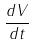<formula> <loc_0><loc_0><loc_500><loc_500>\frac { d V } { d t }</formula> 